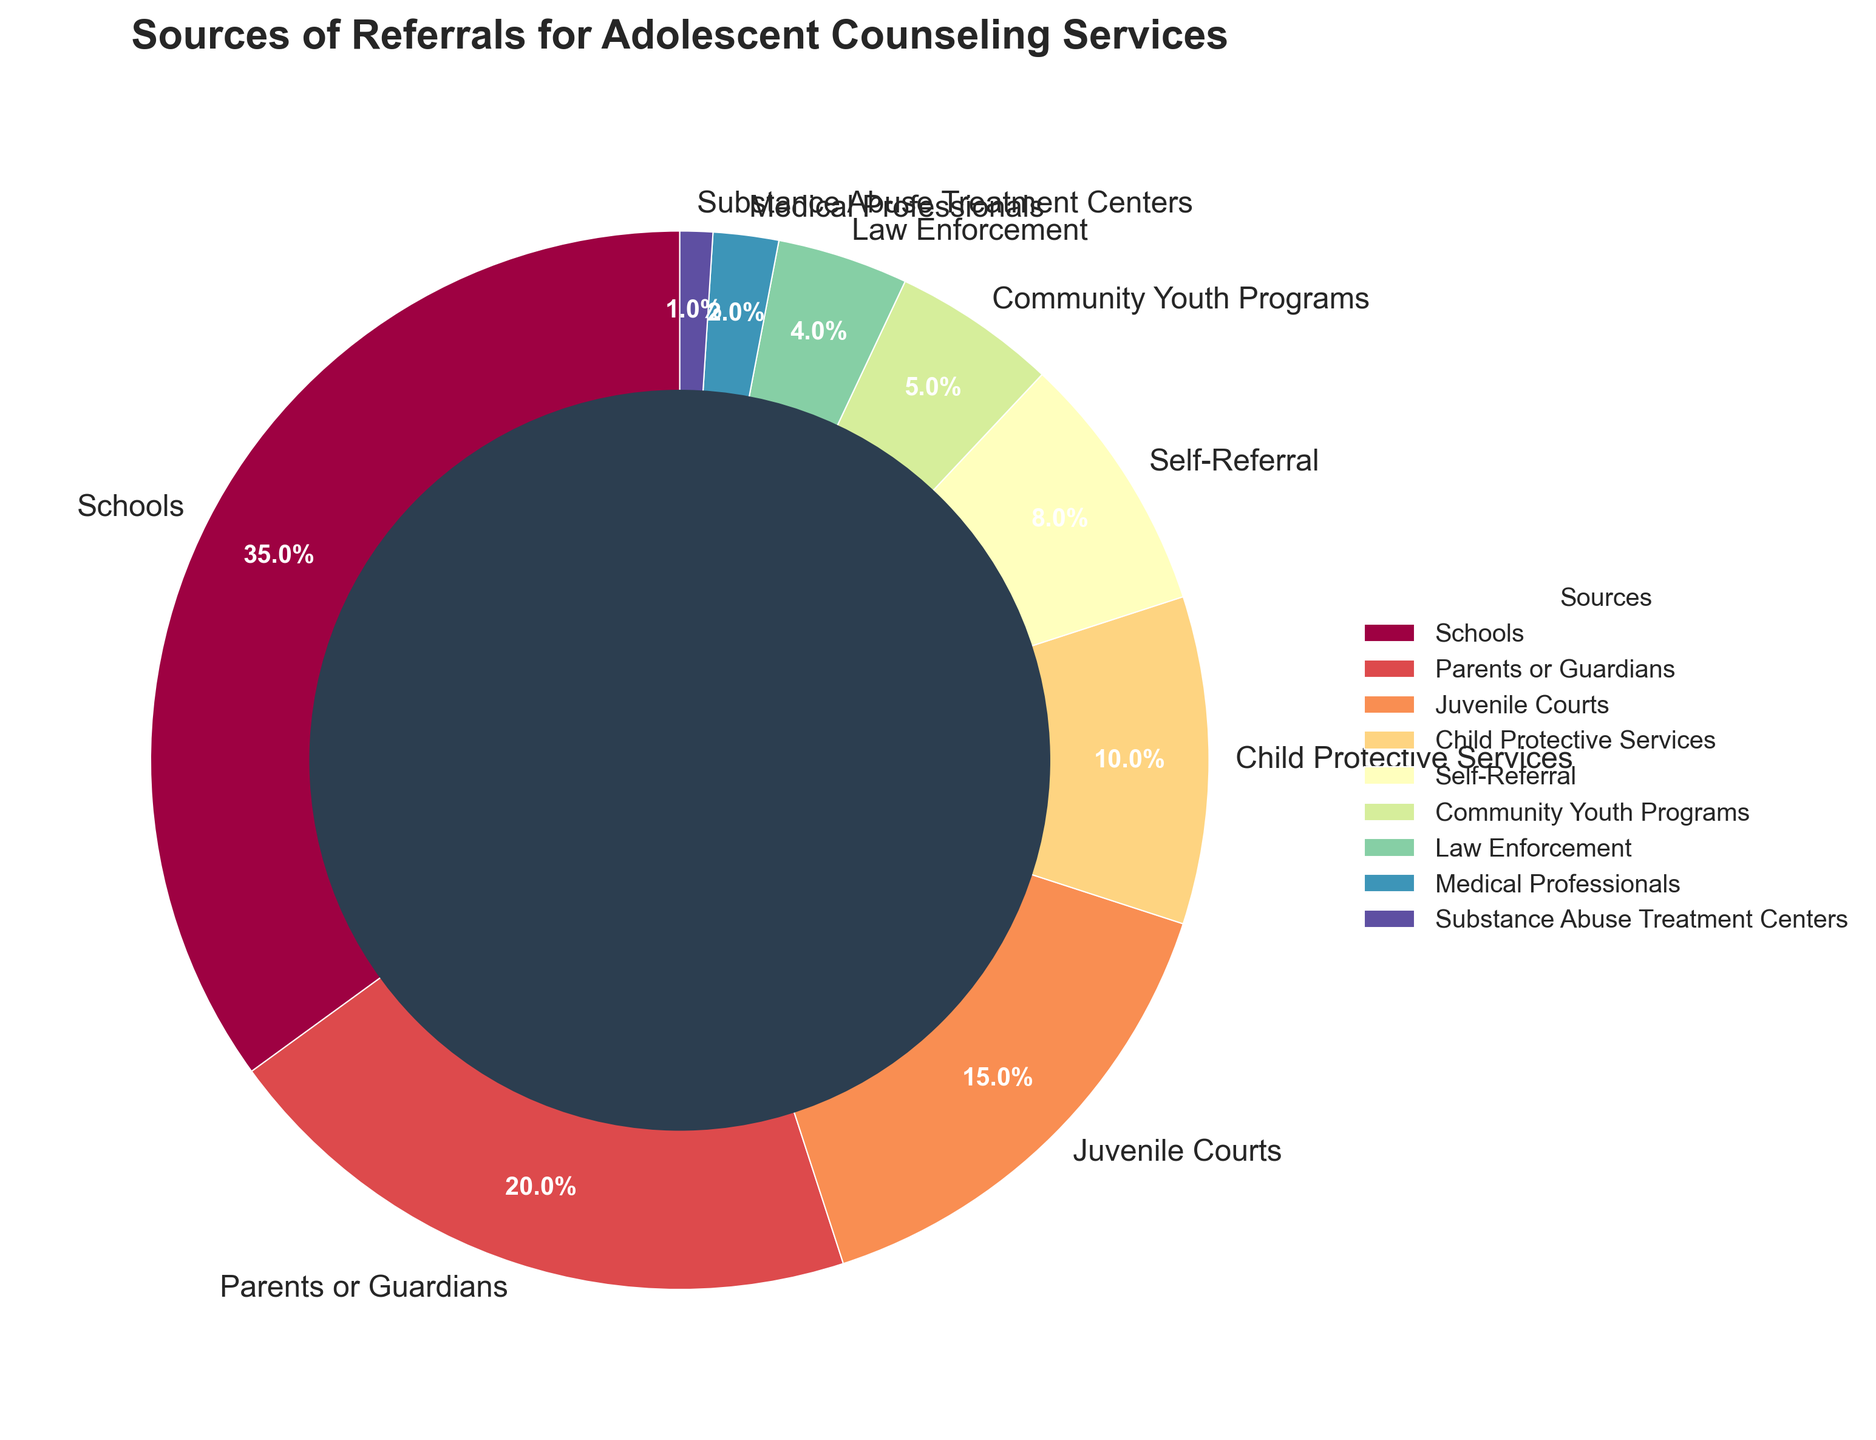What source has the highest percentage of referrals for adolescent counseling services? The legend in the pie chart shows the sources, and "Schools" has the highest percentage slice.
Answer: Schools Which source has a higher percentage, Juvenile Courts or Law Enforcement? By comparing the sizes of the slices for Juvenile Courts and Law Enforcement in the pie chart, Juvenile Courts have a larger slice.
Answer: Juvenile Courts How much more is the combined percentage of Self-Referral and Community Youth Programs compared to the percentage from Medical Professionals? The combined percentage of Self-Referral (8%) and Community Youth Programs (5%) is 8% + 5% = 13%. The percentage from Medical Professionals is 2%. The difference is 13% - 2% = 11%.
Answer: 11% What is the total percentage of referrals coming from Schools, Parents or Guardians, and Child Protective Services? By summing the percentages for Schools (35%), Parents or Guardians (20%), and Child Protective Services (10%), we get 35% + 20% + 10% = 65%.
Answer: 65% Which three sources contribute to at least half of all referrals? From the pie chart, we need to identify the top three sources. Schools (35%), Parents or Guardians (20%), and Juvenile Courts (15%) together contribute 35% + 20% + 15% = 70%. Thus, they contribute to at least half.
Answer: Schools, Parents or Guardians, Juvenile Courts What percentage of referrals come from sources outside of the top three contributors? First, sum the percentages of the top three contributors: Schools (35%), Parents or Guardians (20%), and Juvenile Courts (15%). This totals 35% + 20% + 15% = 70%. The remaining percentage is 100% - 70% = 30%.
Answer: 30% Which source contributes the least to the referrals for adolescent counseling services? By looking at the smallest slice in the pie chart and referencing the legend, Substance Abuse Treatment Centers have the smallest percentage.
Answer: Substance Abuse Treatment Centers How do the referral percentages from Community Youth Programs and Juvenile Courts compare? From the pie chart, we can observe the size of the slices, where Juvenile Courts (15%) have a higher percentage compared to Community Youth Programs (5%).
Answer: Juvenile Courts > Community Youth Programs 